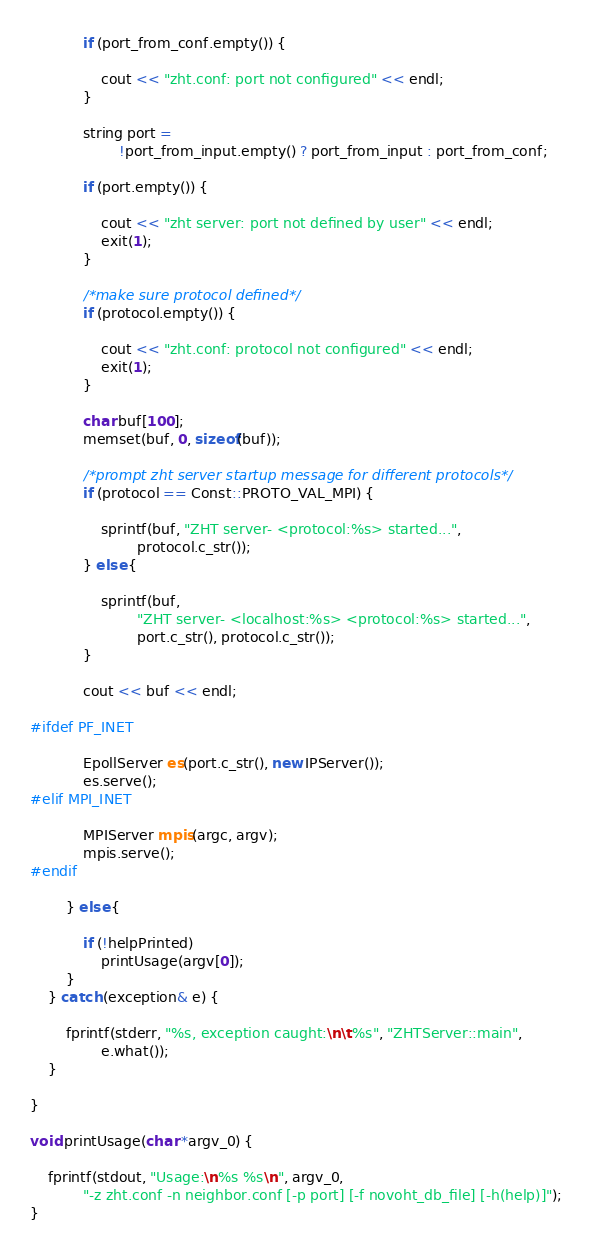<code> <loc_0><loc_0><loc_500><loc_500><_C++_>			if (port_from_conf.empty()) {

				cout << "zht.conf: port not configured" << endl;
			}

			string port =
					!port_from_input.empty() ? port_from_input : port_from_conf;

			if (port.empty()) {

				cout << "zht server: port not defined by user" << endl;
				exit(1);
			}

			/*make sure protocol defined*/
			if (protocol.empty()) {

				cout << "zht.conf: protocol not configured" << endl;
				exit(1);
			}

			char buf[100];
			memset(buf, 0, sizeof(buf));

			/*prompt zht server startup message for different protocols*/
			if (protocol == Const::PROTO_VAL_MPI) {

				sprintf(buf, "ZHT server- <protocol:%s> started...",
						protocol.c_str());
			} else {

				sprintf(buf,
						"ZHT server- <localhost:%s> <protocol:%s> started...",
						port.c_str(), protocol.c_str());
			}

			cout << buf << endl;

#ifdef PF_INET

			EpollServer es(port.c_str(), new IPServer());
			es.serve();
#elif MPI_INET

			MPIServer mpis(argc, argv);
			mpis.serve();
#endif

		} else {

			if (!helpPrinted)
				printUsage(argv[0]);
		}
	} catch (exception& e) {

		fprintf(stderr, "%s, exception caught:\n\t%s", "ZHTServer::main",
				e.what());
	}

}

void printUsage(char *argv_0) {

	fprintf(stdout, "Usage:\n%s %s\n", argv_0,
			"-z zht.conf -n neighbor.conf [-p port] [-f novoht_db_file] [-h(help)]");
}
</code> 